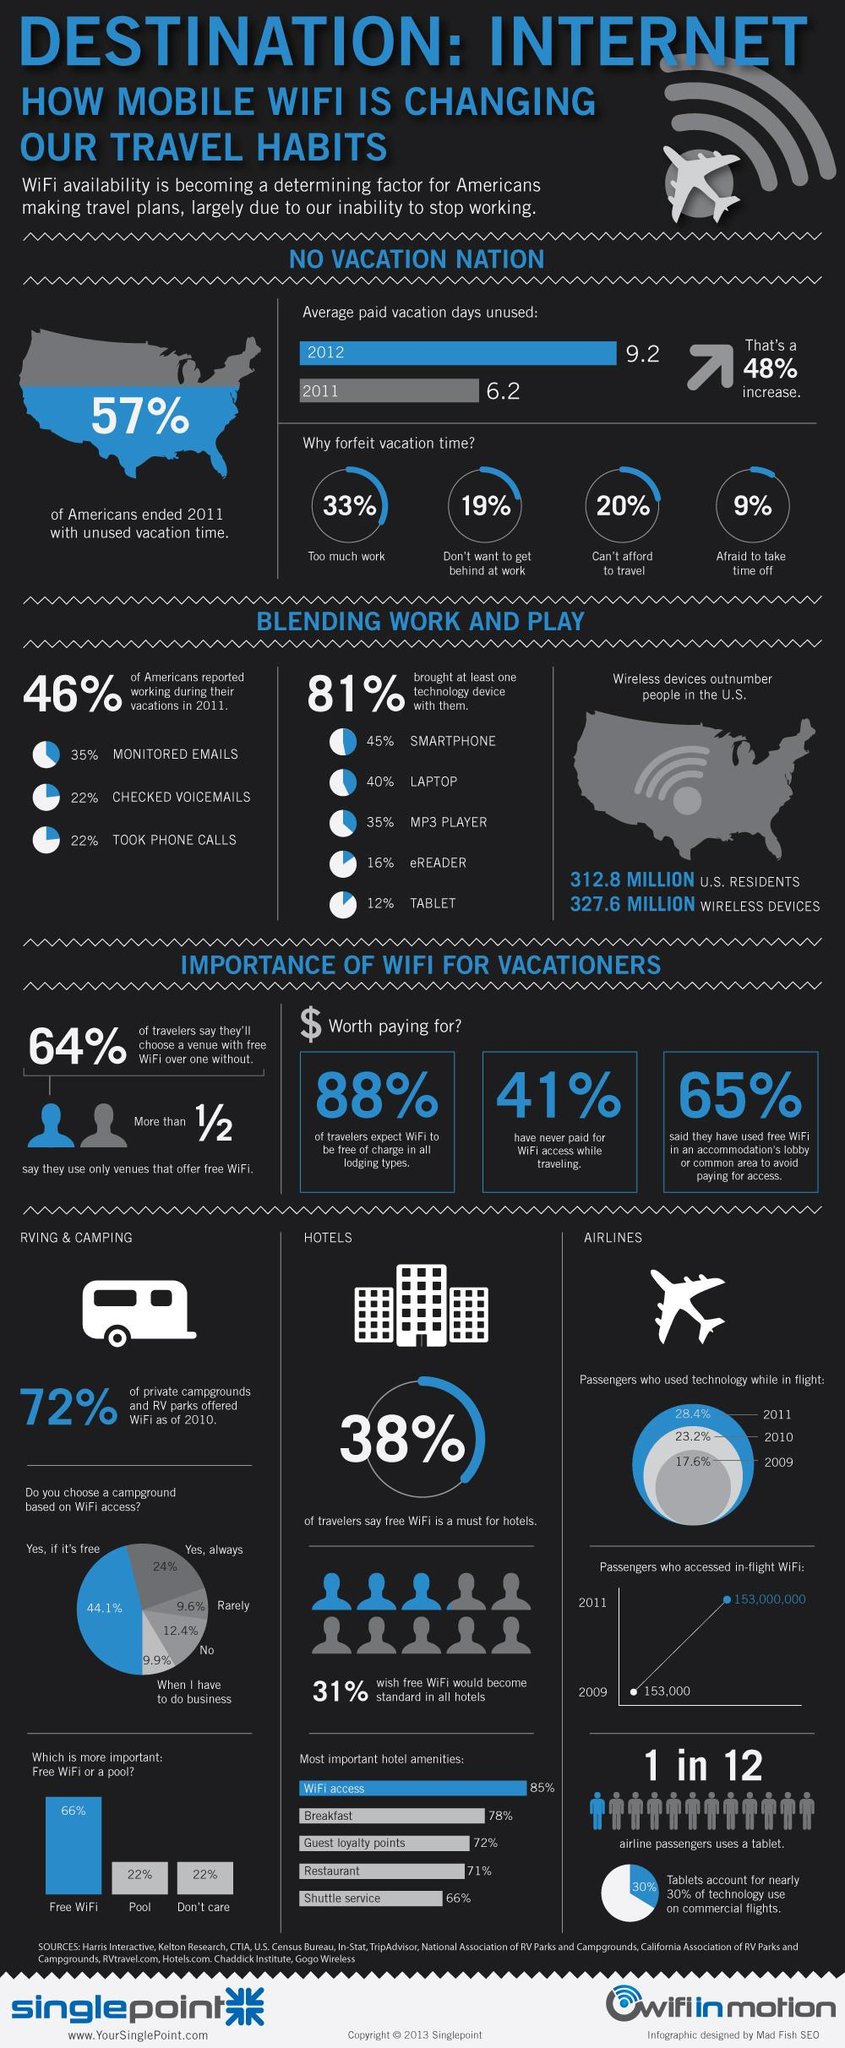Identify some key points in this picture. It is 149% of the combined breakfast and restaurant. Eighty-eight percent of the available WiFi and pool resources have been utilized. I prefer to choose the option that has the highest share, regardless of whether it is free or not. In 2011, a significant percentage of Americans effectively used their vacation time, with 43% successfully utilizing their time off. According to a survey, 59% of people paid for wifi access while traveling. 